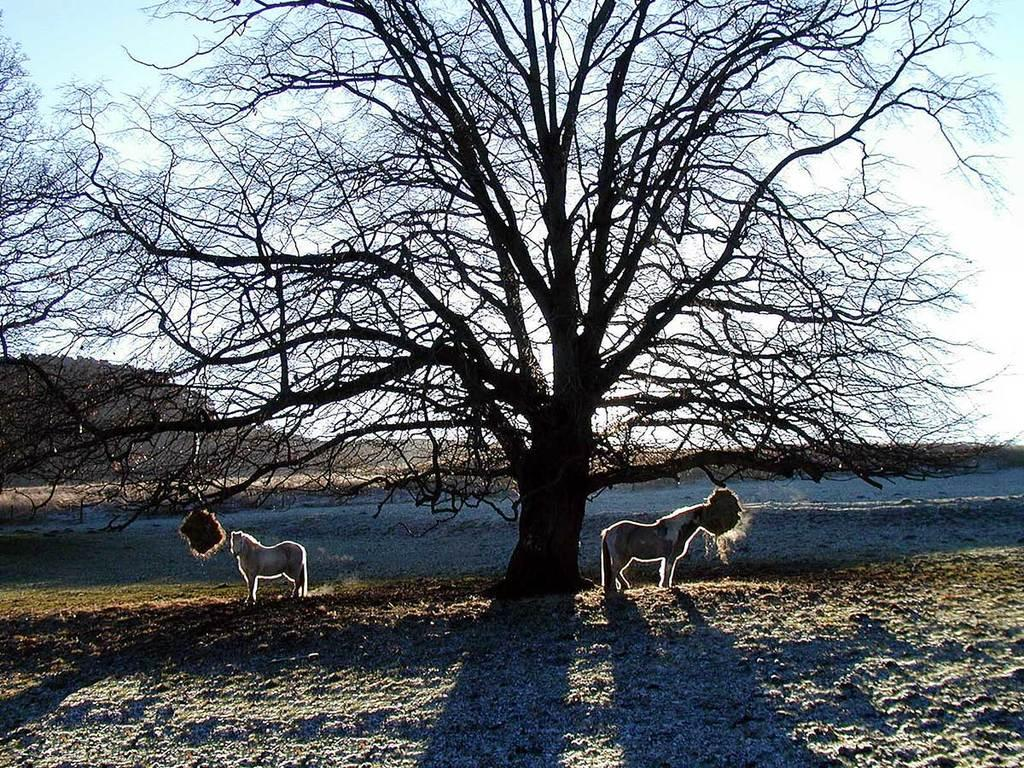What animals can be seen in the image? There are two horses standing on the land in the image. What is located in the middle of the image? There is a dried tree in the middle of the image. What can be seen in the background of the image? There is a hill and the sky visible in the background of the image. How many care tickets are attached to the horses in the image? There are no care tickets present in the image, and the horses are not associated with any tickets. 